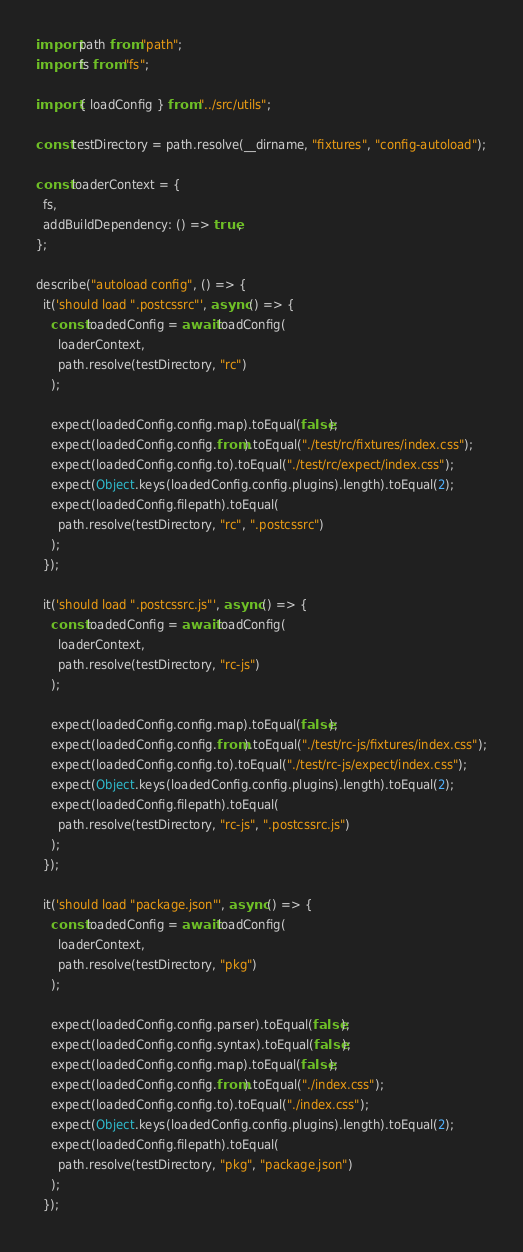Convert code to text. <code><loc_0><loc_0><loc_500><loc_500><_JavaScript_>import path from "path";
import fs from "fs";

import { loadConfig } from "../src/utils";

const testDirectory = path.resolve(__dirname, "fixtures", "config-autoload");

const loaderContext = {
  fs,
  addBuildDependency: () => true,
};

describe("autoload config", () => {
  it('should load ".postcssrc"', async () => {
    const loadedConfig = await loadConfig(
      loaderContext,
      path.resolve(testDirectory, "rc")
    );

    expect(loadedConfig.config.map).toEqual(false);
    expect(loadedConfig.config.from).toEqual("./test/rc/fixtures/index.css");
    expect(loadedConfig.config.to).toEqual("./test/rc/expect/index.css");
    expect(Object.keys(loadedConfig.config.plugins).length).toEqual(2);
    expect(loadedConfig.filepath).toEqual(
      path.resolve(testDirectory, "rc", ".postcssrc")
    );
  });

  it('should load ".postcssrc.js"', async () => {
    const loadedConfig = await loadConfig(
      loaderContext,
      path.resolve(testDirectory, "rc-js")
    );

    expect(loadedConfig.config.map).toEqual(false);
    expect(loadedConfig.config.from).toEqual("./test/rc-js/fixtures/index.css");
    expect(loadedConfig.config.to).toEqual("./test/rc-js/expect/index.css");
    expect(Object.keys(loadedConfig.config.plugins).length).toEqual(2);
    expect(loadedConfig.filepath).toEqual(
      path.resolve(testDirectory, "rc-js", ".postcssrc.js")
    );
  });

  it('should load "package.json"', async () => {
    const loadedConfig = await loadConfig(
      loaderContext,
      path.resolve(testDirectory, "pkg")
    );

    expect(loadedConfig.config.parser).toEqual(false);
    expect(loadedConfig.config.syntax).toEqual(false);
    expect(loadedConfig.config.map).toEqual(false);
    expect(loadedConfig.config.from).toEqual("./index.css");
    expect(loadedConfig.config.to).toEqual("./index.css");
    expect(Object.keys(loadedConfig.config.plugins).length).toEqual(2);
    expect(loadedConfig.filepath).toEqual(
      path.resolve(testDirectory, "pkg", "package.json")
    );
  });
</code> 